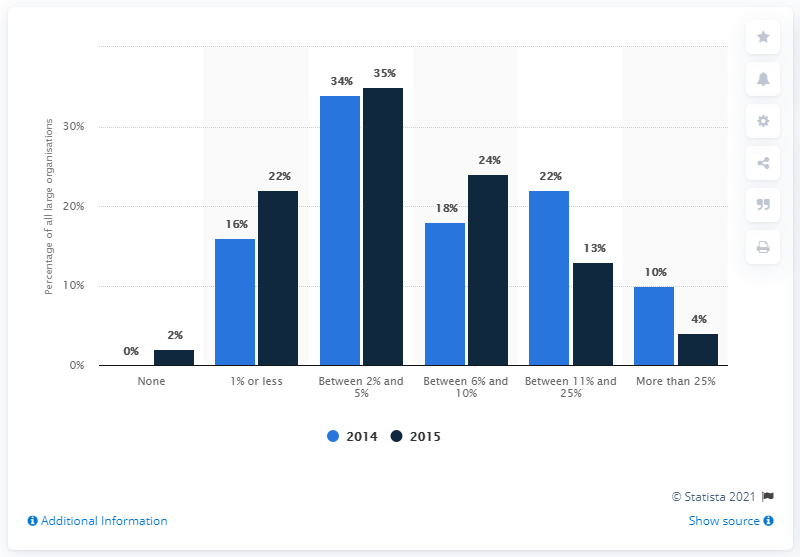Mention a couple of crucial points in this snapshot. In 2014, a significant percentage of large organizations allocated between 11 and 25 percent of their IT budgets towards information security. 